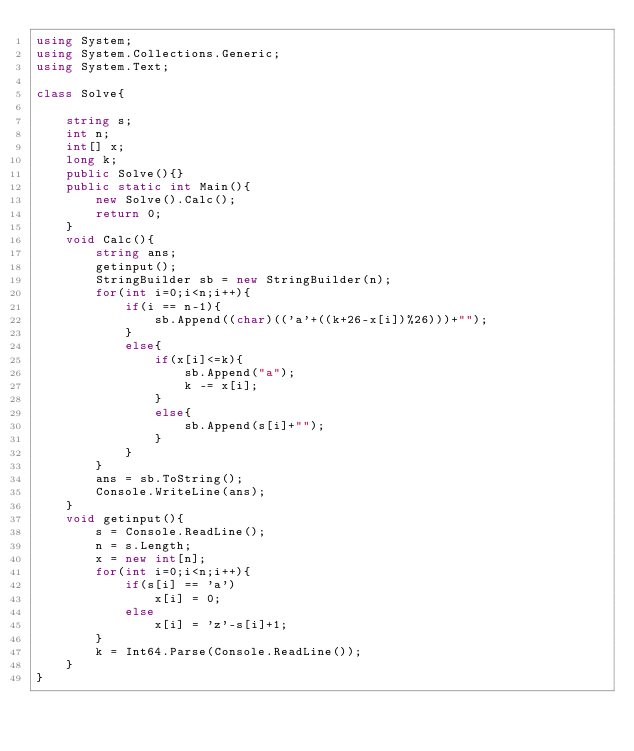Convert code to text. <code><loc_0><loc_0><loc_500><loc_500><_C#_>using System;
using System.Collections.Generic;
using System.Text;

class Solve{
    
    string s;
    int n;
    int[] x;
    long k;
    public Solve(){}
    public static int Main(){
        new Solve().Calc();
        return 0;
    }
    void Calc(){
        string ans;
        getinput();
        StringBuilder sb = new StringBuilder(n);
        for(int i=0;i<n;i++){
            if(i == n-1){
                sb.Append((char)(('a'+((k+26-x[i])%26)))+"");
            }
            else{
                if(x[i]<=k){
                    sb.Append("a");
                    k -= x[i];
                }
                else{
                    sb.Append(s[i]+"");
                }
            }
        }
        ans = sb.ToString();
        Console.WriteLine(ans);
    }
    void getinput(){
        s = Console.ReadLine();
        n = s.Length;
        x = new int[n];
        for(int i=0;i<n;i++){
            if(s[i] == 'a')
                x[i] = 0;
            else
                x[i] = 'z'-s[i]+1;
        }
        k = Int64.Parse(Console.ReadLine());
    }    
}</code> 